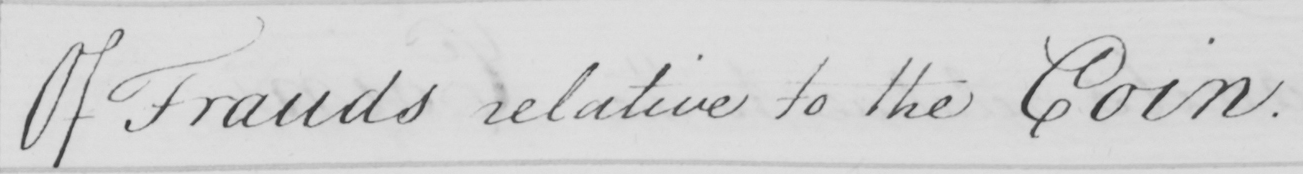Transcribe the text shown in this historical manuscript line. Of Frauds relative to the Coin . 